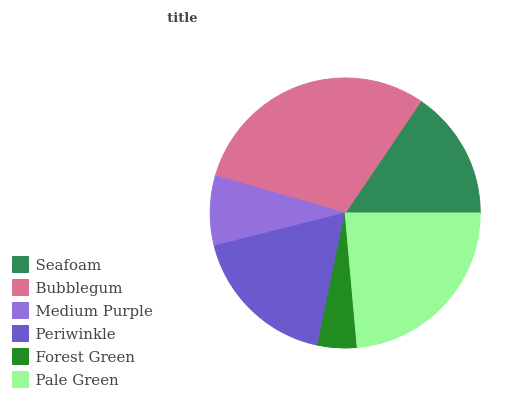Is Forest Green the minimum?
Answer yes or no. Yes. Is Bubblegum the maximum?
Answer yes or no. Yes. Is Medium Purple the minimum?
Answer yes or no. No. Is Medium Purple the maximum?
Answer yes or no. No. Is Bubblegum greater than Medium Purple?
Answer yes or no. Yes. Is Medium Purple less than Bubblegum?
Answer yes or no. Yes. Is Medium Purple greater than Bubblegum?
Answer yes or no. No. Is Bubblegum less than Medium Purple?
Answer yes or no. No. Is Periwinkle the high median?
Answer yes or no. Yes. Is Seafoam the low median?
Answer yes or no. Yes. Is Medium Purple the high median?
Answer yes or no. No. Is Periwinkle the low median?
Answer yes or no. No. 